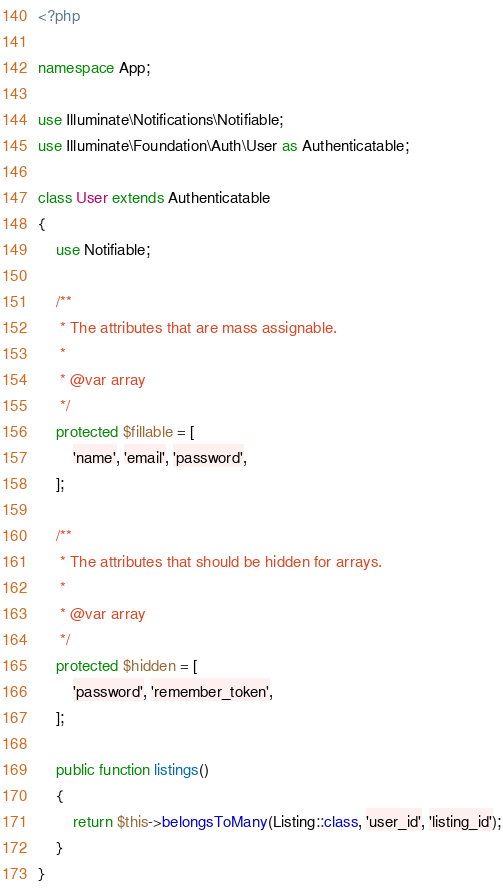<code> <loc_0><loc_0><loc_500><loc_500><_PHP_><?php

namespace App;

use Illuminate\Notifications\Notifiable;
use Illuminate\Foundation\Auth\User as Authenticatable;

class User extends Authenticatable
{
    use Notifiable;

    /**
     * The attributes that are mass assignable.
     *
     * @var array
     */
    protected $fillable = [
        'name', 'email', 'password',
    ];

    /**
     * The attributes that should be hidden for arrays.
     *
     * @var array
     */
    protected $hidden = [
        'password', 'remember_token',
    ];

    public function listings()
    {
        return $this->belongsToMany(Listing::class, 'user_id', 'listing_id');
    }
}
</code> 